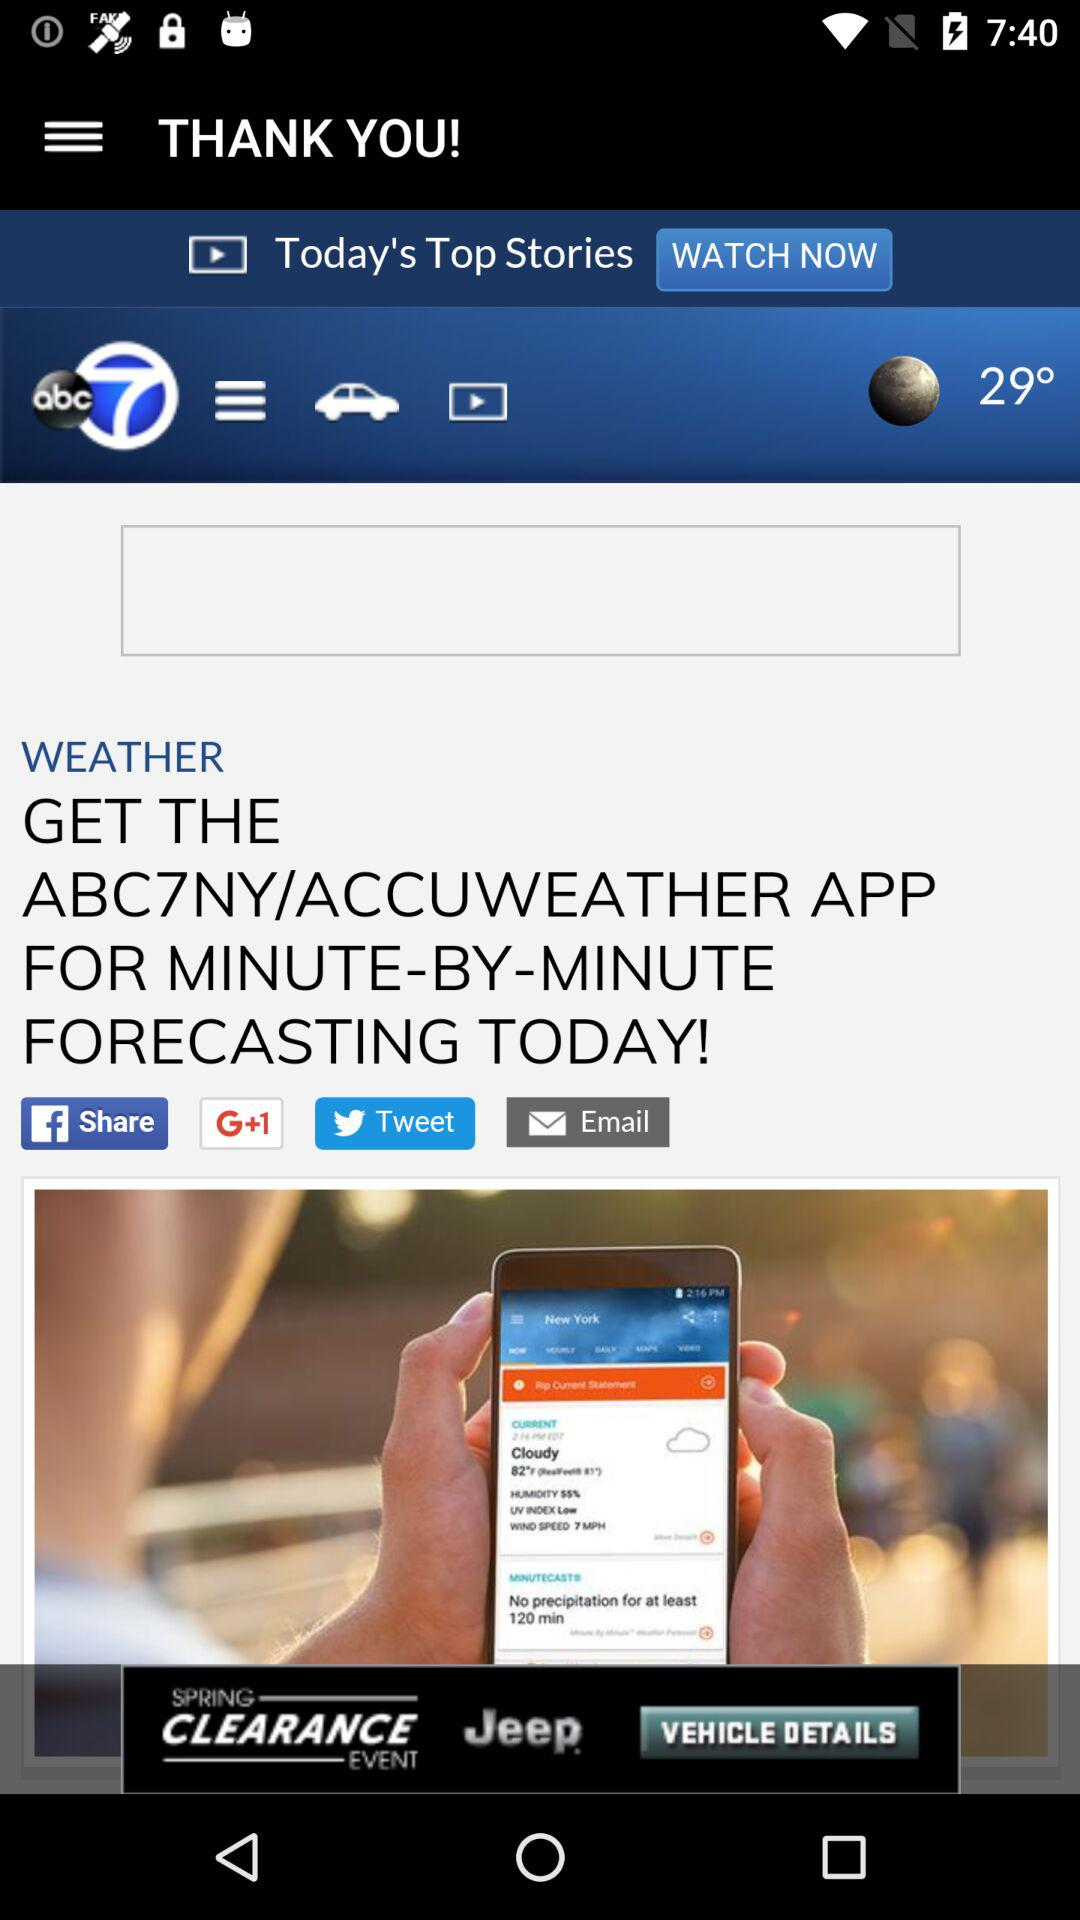How many degrees is the current temperature?
Answer the question using a single word or phrase. 29° 